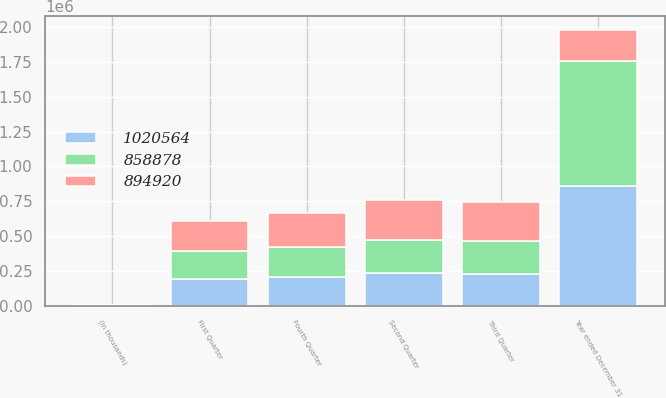Convert chart. <chart><loc_0><loc_0><loc_500><loc_500><stacked_bar_chart><ecel><fcel>(in thousands)<fcel>First Quarter<fcel>Second Quarter<fcel>Third Quarter<fcel>Fourth Quarter<fcel>Year ended December 31<nl><fcel>894920<fcel>2008<fcel>210078<fcel>284499<fcel>277911<fcel>248076<fcel>227816<nl><fcel>858878<fcel>2007<fcel>201232<fcel>239618<fcel>238116<fcel>215954<fcel>894920<nl><fcel>1.02056e+06<fcel>2006<fcel>194187<fcel>232222<fcel>227816<fcel>204653<fcel>858878<nl></chart> 